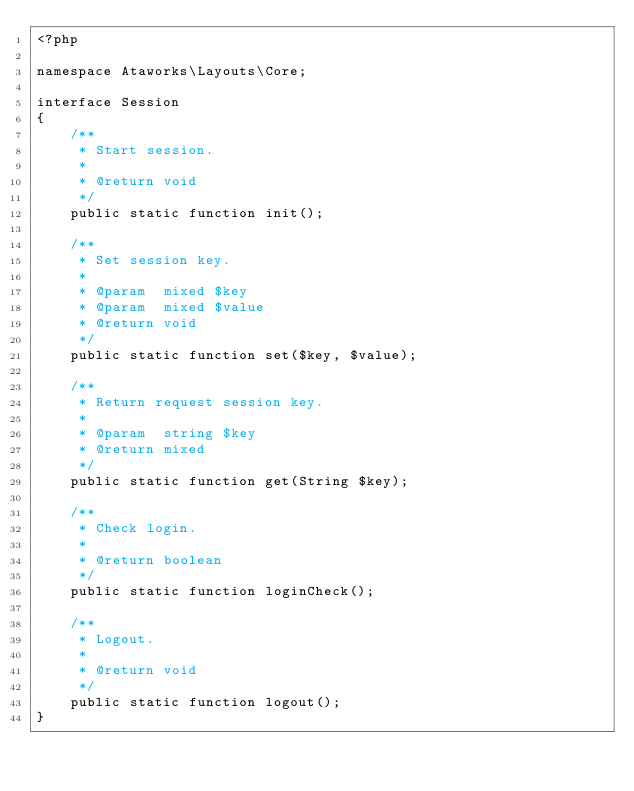Convert code to text. <code><loc_0><loc_0><loc_500><loc_500><_PHP_><?php

namespace Ataworks\Layouts\Core;

interface Session
{
    /**
     * Start session.
     *
     * @return void
     */
    public static function init();

    /**
     * Set session key.
     *
     * @param  mixed $key
     * @param  mixed $value
     * @return void
     */
    public static function set($key, $value);

    /**
     * Return request session key.
     *
     * @param  string $key
     * @return mixed
     */
    public static function get(String $key);

    /**
     * Check login.
     *
     * @return boolean
     */
    public static function loginCheck();

    /**
     * Logout.
     *
     * @return void
     */
    public static function logout();
}
</code> 